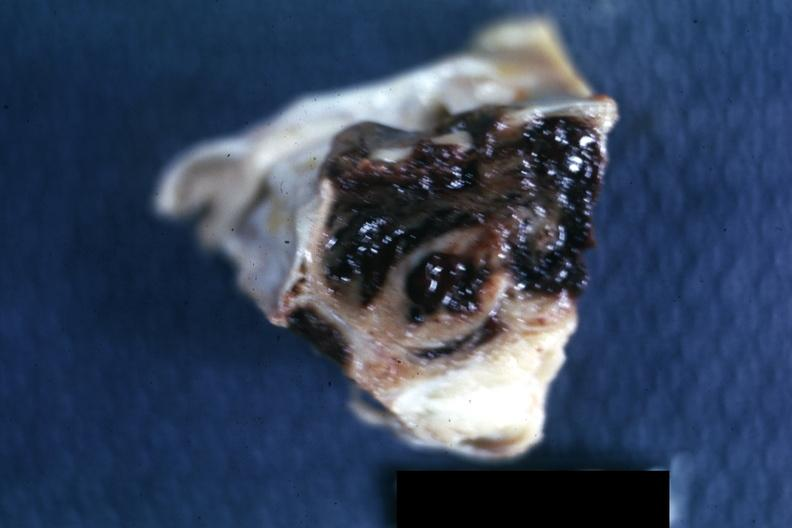s endocrine present?
Answer the question using a single word or phrase. Yes 